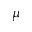Convert formula to latex. <formula><loc_0><loc_0><loc_500><loc_500>\mu</formula> 